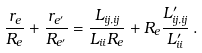<formula> <loc_0><loc_0><loc_500><loc_500>\frac { r _ { e } } { R _ { e } } + \frac { r _ { e ^ { \prime } } } { R _ { e ^ { \prime } } } = \frac { L _ { i j , i j } } { L _ { i i } R _ { e } } + R _ { e } \frac { L ^ { \prime } _ { i j , i j } } { L ^ { \prime } _ { i i } } \, .</formula> 